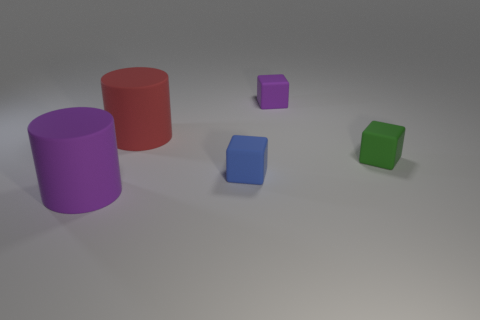How many cylinders are either tiny green matte objects or big matte objects?
Make the answer very short. 2. Do the big cylinder that is in front of the red cylinder and the large thing behind the purple cylinder have the same material?
Offer a terse response. Yes. There is a blue matte thing that is the same size as the purple block; what is its shape?
Keep it short and to the point. Cube. How many blue objects are either blocks or large matte things?
Give a very brief answer. 1. There is a tiny thing that is on the left side of the small purple block; is its shape the same as the large thing that is in front of the small green block?
Give a very brief answer. No. How many other things are there of the same material as the tiny blue cube?
Keep it short and to the point. 4. Is there a green object left of the small matte object that is left of the rubber block that is behind the red cylinder?
Keep it short and to the point. No. Are the big purple object and the red object made of the same material?
Your response must be concise. Yes. Is there anything else that is the same shape as the red matte thing?
Give a very brief answer. Yes. There is a tiny cube to the left of the rubber block behind the green rubber object; what is it made of?
Your answer should be compact. Rubber. 